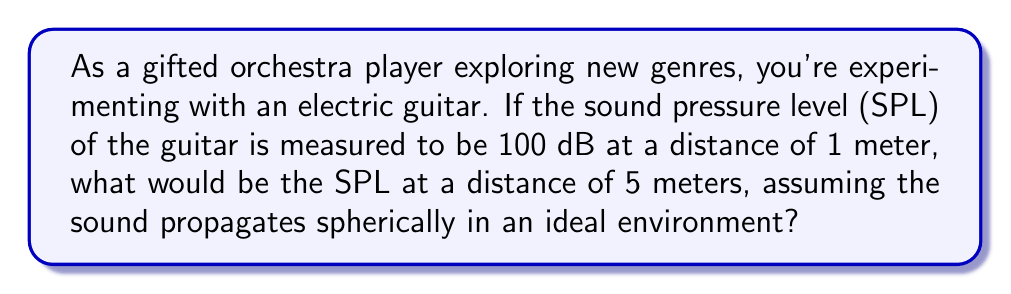Solve this math problem. To solve this problem, we'll use the inverse square law for sound intensity and the relationship between sound intensity and sound pressure level.

1. The inverse square law states that sound intensity is inversely proportional to the square of the distance from the source:

   $$ I_1 r_1^2 = I_2 r_2^2 $$

   where $I$ is intensity and $r$ is distance.

2. The relationship between sound pressure level (SPL) and intensity is:

   $$ SPL = 10 \log_{10} \left(\frac{I}{I_0}\right) $$

   where $I_0$ is the reference intensity (10^-12 W/m^2).

3. Let's denote the initial conditions (1 meter) with subscript 1 and the new conditions (5 meters) with subscript 2.

4. We can express the ratio of intensities using the inverse square law:

   $$ \frac{I_2}{I_1} = \left(\frac{r_1}{r_2}\right)^2 = \left(\frac{1}{5}\right)^2 = \frac{1}{25} $$

5. Now, let's use the SPL equation:

   $$ SPL_1 - SPL_2 = 10 \log_{10} \left(\frac{I_1}{I_2}\right) $$

6. Substituting the intensity ratio:

   $$ SPL_1 - SPL_2 = 10 \log_{10} (25) = 10 \cdot 1.398 = 13.98 \text{ dB} $$

7. Given that $SPL_1 = 100 \text{ dB}$, we can find $SPL_2$:

   $$ SPL_2 = SPL_1 - 13.98 = 100 - 13.98 = 86.02 \text{ dB} $$
Answer: 86.02 dB 